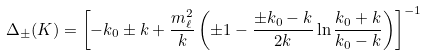<formula> <loc_0><loc_0><loc_500><loc_500>\Delta _ { \pm } ( K ) = \left [ - k _ { 0 } \pm k + \frac { m _ { \ell } ^ { 2 } } { k } \left ( \pm 1 - \frac { \pm k _ { 0 } - k } { 2 k } \ln \frac { k _ { 0 } + k } { k _ { 0 } - k } \right ) \right ] ^ { - 1 }</formula> 